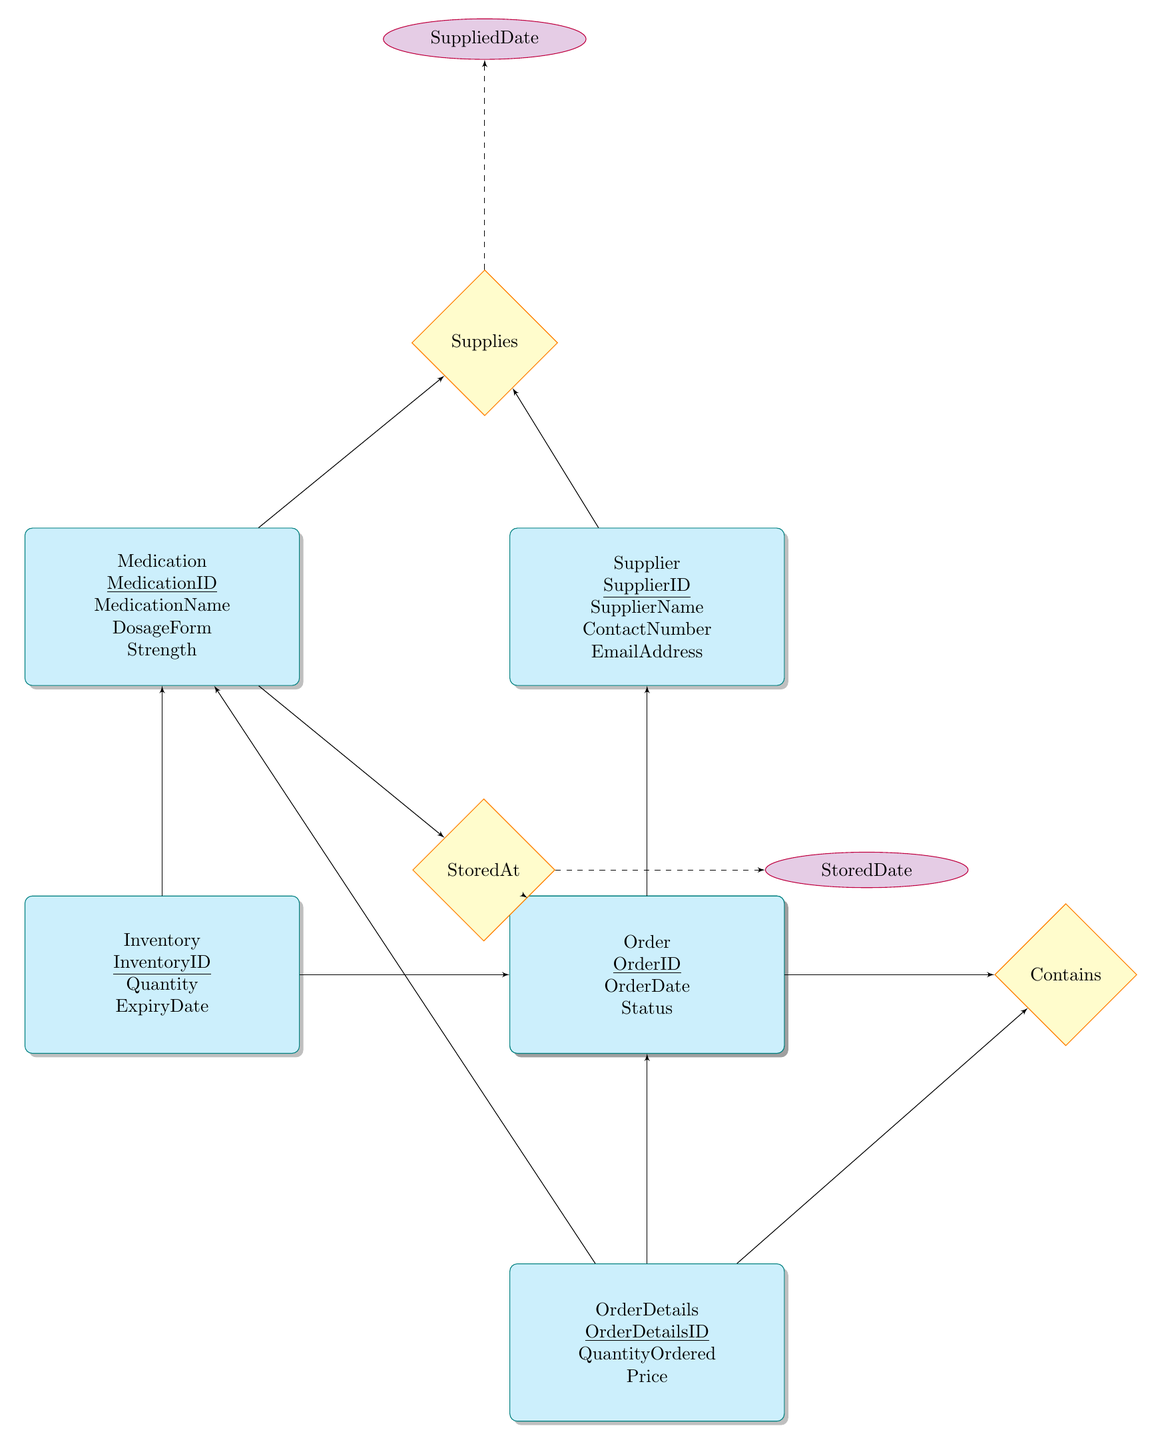What is the primary key of the Medication entity? The primary key of the Medication entity is indicated in the diagram as MedicationID, which is underlined in the outline of the Medication entity box.
Answer: MedicationID How many attributes does the Supplier entity have? To find the number of attributes in the Supplier entity, count the listed items: SupplierID, SupplierName, ContactNumber, and EmailAddress, which totals four attributes.
Answer: 4 Which two entities have a relationship called "StoredAt"? The relationship "StoredAt" connects the Medication and Location entities. You can see it in the diagram as a diamond labeled "StoredAt" with lines connecting to both the Medication and Location entities.
Answer: Medication, Location What is the name of the relationship between Order and OrderDetails? The name of the relationship is "Contains", which is shown in the diagram as a diamond connecting the Order entity to the OrderDetails entity.
Answer: Contains Which attribute is associated with the relationship "Supplies"? The attribute associated with the "Supplies" relationship is SuppliedDate, as indicated by the dashed line connecting the Supplies diamond to the SuppliedDate ellipse above it.
Answer: SuppliedDate How many foreign keys are present in the Inventory entity? The Inventory entity has two foreign keys: MedicationID (linking to the Medication entity) and LocationID (linking to the Location entity). This can be determined by viewing the foreignKey section in the inventory entity box.
Answer: 2 What does the Order entity primarily represent? The Order entity represents requests for medication, as indicated by its attributes including OrderID, OrderDate, and Status, which reflect the aspects of an order in an inventory system.
Answer: Requests for medication Which entity is related to both Medication and Location? The Inventory entity is related to both the Medication entity (through the foreign key MedicationID) and the Location entity (through the foreign key LocationID), forming connections as shown by the lines from Inventory to both entities.
Answer: Inventory 